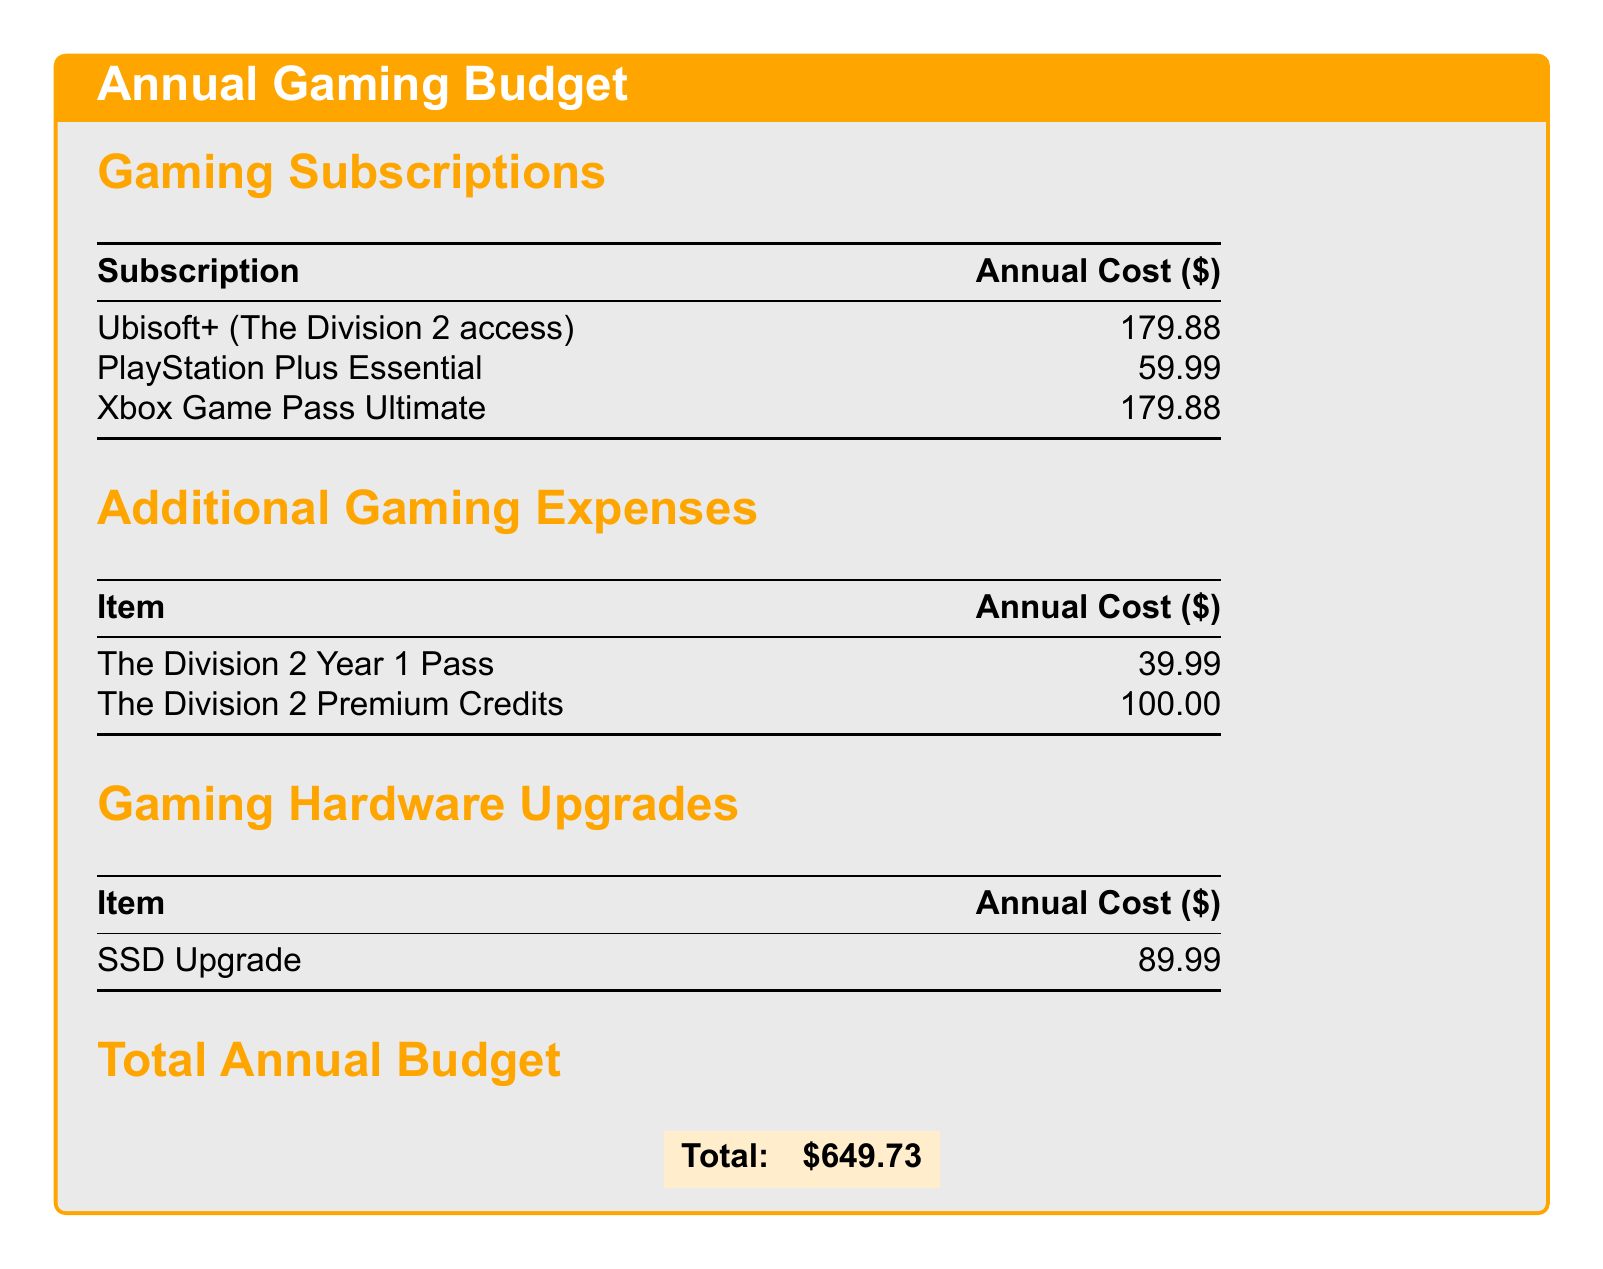what is the annual cost of Ubisoft+? The document lists Ubisoft+ with an annual cost of $179.88.
Answer: $179.88 how much does the SSD upgrade cost? The document specifies that the SSD upgrade costs $89.99.
Answer: $89.99 what is the total annual budget? The total annual budget is displayed as $649.73 in the document.
Answer: $649.73 how much do you need to spend on The Division 2 Year 1 Pass? The cost for The Division 2 Year 1 Pass is mentioned as $39.99.
Answer: $39.99 what is the annual cost of Xbox Game Pass Ultimate? The document indicates that Xbox Game Pass Ultimate costs $179.88 annually.
Answer: $179.88 what are the total costs of gaming hardware upgrades? The document shows that there is one item in hardware upgrades, the SSD, totaling $89.99.
Answer: $89.99 how much do Premium Credits for The Division 2 cost? The document states that The Division 2 Premium Credits cost $100.00.
Answer: $100.00 which subscription costs the least? Among the subscriptions listed, PlayStation Plus Essential costs $59.99, which is the least.
Answer: PlayStation Plus Essential what is the expense category for the Year 1 Pass? The Year 1 Pass is categorized under Additional Gaming Expenses in the document.
Answer: Additional Gaming Expenses 